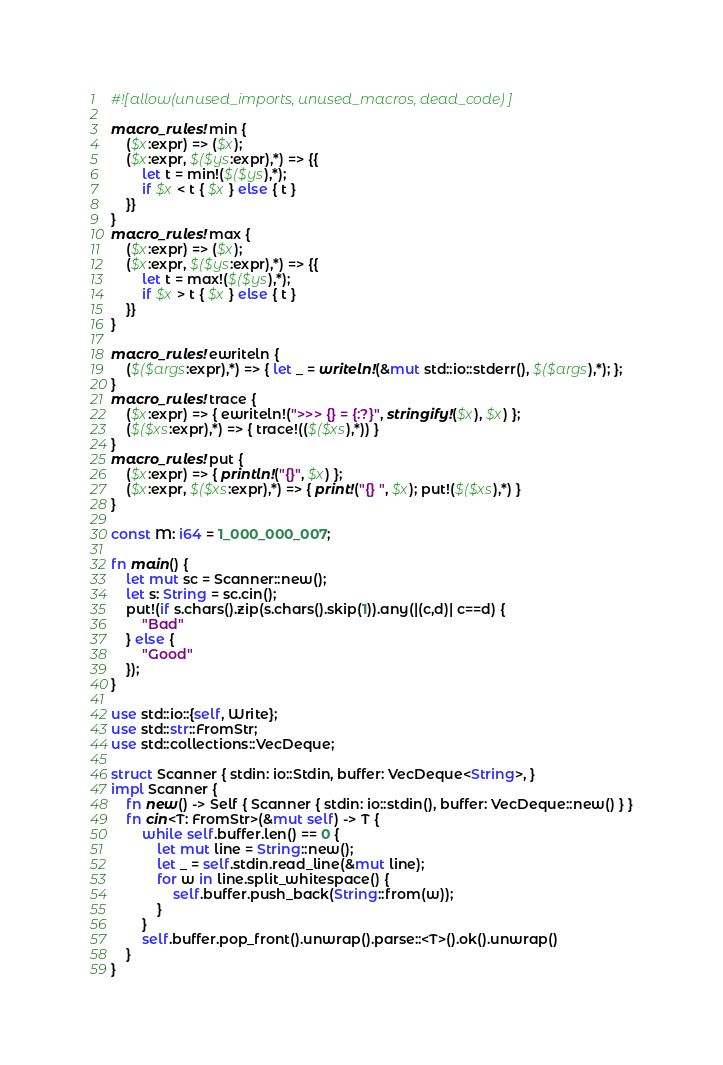Convert code to text. <code><loc_0><loc_0><loc_500><loc_500><_Rust_>#![allow(unused_imports, unused_macros, dead_code)]

macro_rules! min {
    ($x:expr) => ($x);
    ($x:expr, $($ys:expr),*) => {{
        let t = min!($($ys),*);
        if $x < t { $x } else { t }
    }}
}
macro_rules! max {
    ($x:expr) => ($x);
    ($x:expr, $($ys:expr),*) => {{
        let t = max!($($ys),*);
        if $x > t { $x } else { t }
    }}
}

macro_rules! ewriteln {
    ($($args:expr),*) => { let _ = writeln!(&mut std::io::stderr(), $($args),*); };
}
macro_rules! trace {
    ($x:expr) => { ewriteln!(">>> {} = {:?}", stringify!($x), $x) };
    ($($xs:expr),*) => { trace!(($($xs),*)) }
}
macro_rules! put {
    ($x:expr) => { println!("{}", $x) };
    ($x:expr, $($xs:expr),*) => { print!("{} ", $x); put!($($xs),*) }
}

const M: i64 = 1_000_000_007;

fn main() {
    let mut sc = Scanner::new();
    let s: String = sc.cin();
    put!(if s.chars().zip(s.chars().skip(1)).any(|(c,d)| c==d) {
        "Bad"
    } else {
        "Good"
    });
}

use std::io::{self, Write};
use std::str::FromStr;
use std::collections::VecDeque;

struct Scanner { stdin: io::Stdin, buffer: VecDeque<String>, }
impl Scanner {
    fn new() -> Self { Scanner { stdin: io::stdin(), buffer: VecDeque::new() } }
    fn cin<T: FromStr>(&mut self) -> T {
        while self.buffer.len() == 0 {
            let mut line = String::new();
            let _ = self.stdin.read_line(&mut line);
            for w in line.split_whitespace() {
                self.buffer.push_back(String::from(w));
            }
        }
        self.buffer.pop_front().unwrap().parse::<T>().ok().unwrap()
    }
}
</code> 